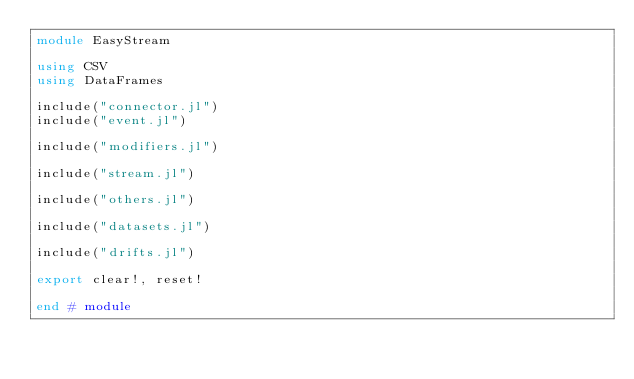<code> <loc_0><loc_0><loc_500><loc_500><_Julia_>module EasyStream

using CSV
using DataFrames

include("connector.jl")
include("event.jl")

include("modifiers.jl")

include("stream.jl")

include("others.jl")

include("datasets.jl")

include("drifts.jl")

export clear!, reset!

end # module
</code> 